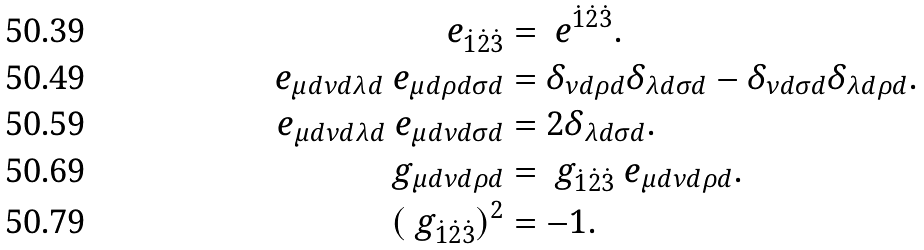<formula> <loc_0><loc_0><loc_500><loc_500>\ e _ { \dot { 1 } \dot { 2 } \dot { 3 } } & = \ e ^ { \dot { 1 } \dot { 2 } \dot { 3 } } . \\ \ e _ { \mu d \nu d \lambda d } \ e _ { \mu d \rho d \sigma d } & = \delta _ { \nu d \rho d } \delta _ { \lambda d \sigma d } - \delta _ { \nu d \sigma d } \delta _ { \lambda d \rho d } . \\ \ e _ { \mu d \nu d \lambda d } \ e _ { \mu d \nu d \sigma d } & = 2 \delta _ { \lambda d \sigma d } . \\ \ g _ { \mu d \nu d \rho d } & = \ g _ { \dot { 1 } \dot { 2 } \dot { 3 } } \ e _ { \mu d \nu d \rho d } . \\ ( \ g _ { \dot { 1 } \dot { 2 } \dot { 3 } } ) ^ { 2 } & = - 1 .</formula> 